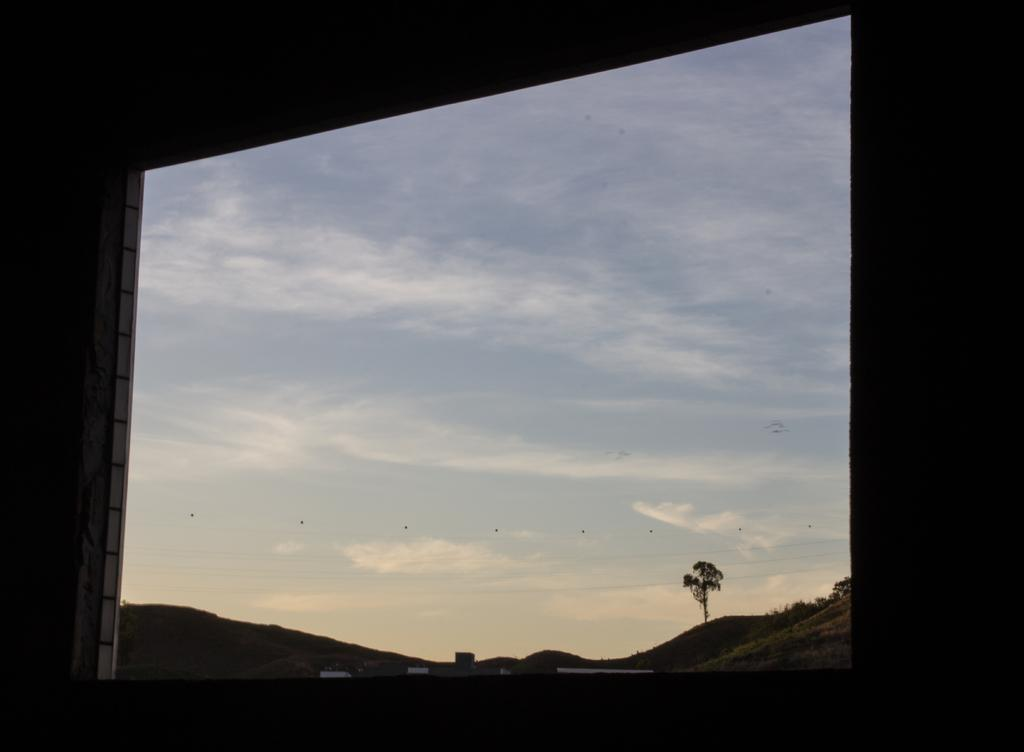What can be seen in the background of the image? The sky is visible in the image. Are there any weather conditions indicated by the sky? Yes, there are clouds in the image, which suggests a partly cloudy day. What is visible through the window in the image? There is a tree visible through a window in the image. How many feet of jelly can be seen hanging from the tree in the image? There is no jelly present in the image, and therefore no such hanging can be observed. 